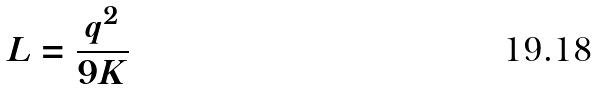Convert formula to latex. <formula><loc_0><loc_0><loc_500><loc_500>L = \frac { q ^ { 2 } } { 9 K }</formula> 